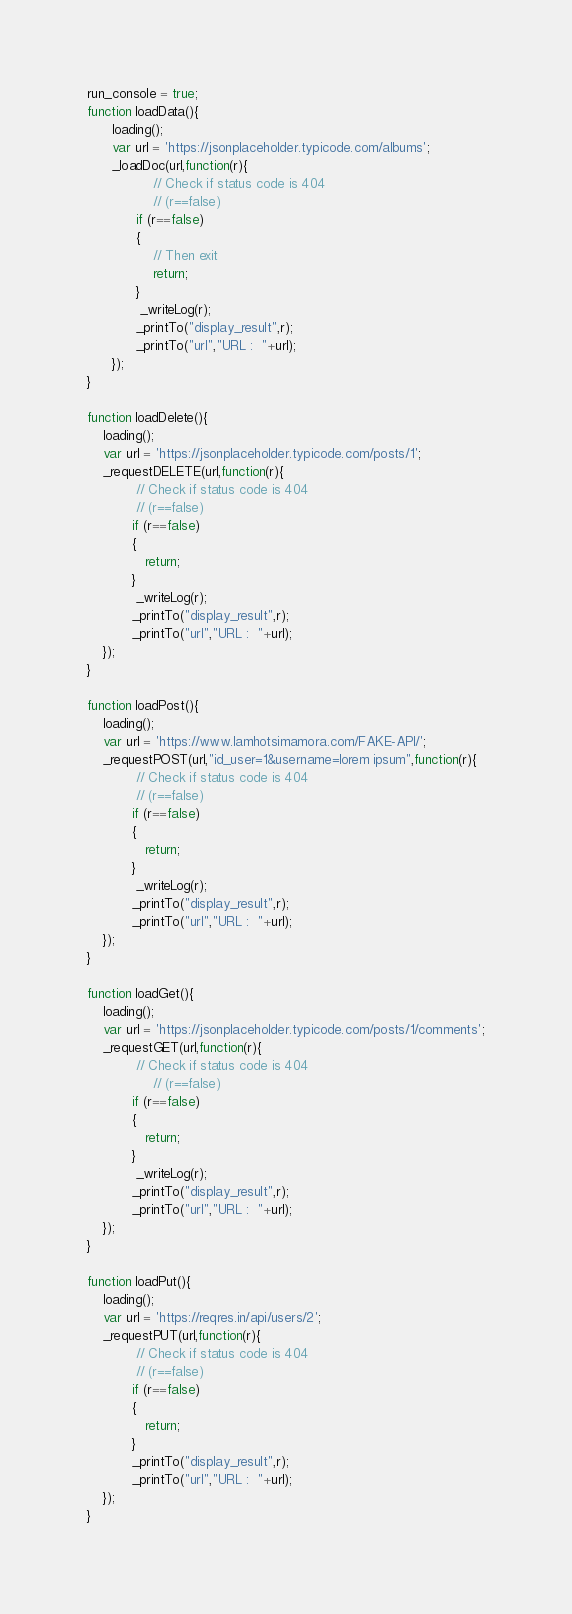Convert code to text. <code><loc_0><loc_0><loc_500><loc_500><_JavaScript_>run_console = true;
function loadData(){
	  loading();
	  var url = 'https://jsonplaceholder.typicode.com/albums';
	  _loadDoc(url,function(r){
		        // Check if status code is 404 
		        // (r==false)
	  		if (r==false)
	  		{
				// Then exit
	  			return;
	  		}
	  		 _writeLog(r);
	  		_printTo("display_result",r);
	  		_printTo("url","URL :  "+url);
	  });
}

function loadDelete(){
	loading();
	var url = 'https://jsonplaceholder.typicode.com/posts/1';
	_requestDELETE(url,function(r){
		    // Check if status code is 404 
		    // (r==false)
		   if (r==false)
		   {
		   	  return;
		   }
		    _writeLog(r);
		   _printTo("display_result",r);
		   _printTo("url","URL :  "+url);
	});
}

function loadPost(){
	loading();
	var url = 'https://www.lamhotsimamora.com/FAKE-API/';
	_requestPOST(url,"id_user=1&username=lorem ipsum",function(r){
		    // Check if status code is 404 
		    // (r==false)
		   if (r==false)
		   {
		   	  return;
		   }
		    _writeLog(r);
		   _printTo("display_result",r);
		   _printTo("url","URL :  "+url);
	});
}

function loadGet(){
	loading();
	var url = 'https://jsonplaceholder.typicode.com/posts/1/comments';
	_requestGET(url,function(r){
		    // Check if status code is 404 
		        // (r==false)
		   if (r==false)
		   {
		   	  return;
		   }
		    _writeLog(r);
		   _printTo("display_result",r);
		   _printTo("url","URL :  "+url);
	});
}

function loadPut(){
	loading();
	var url = 'https://reqres.in/api/users/2';
	_requestPUT(url,function(r){
		    // Check if status code is 404 
		    // (r==false)
		   if (r==false)
		   {
		   	  return;
		   }
		   _printTo("display_result",r);
		   _printTo("url","URL :  "+url);
	});
}

</code> 